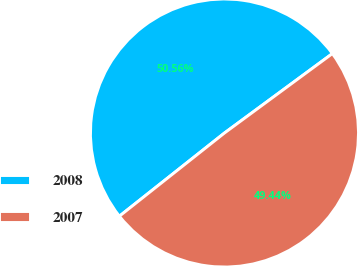Convert chart to OTSL. <chart><loc_0><loc_0><loc_500><loc_500><pie_chart><fcel>2008<fcel>2007<nl><fcel>50.56%<fcel>49.44%<nl></chart> 